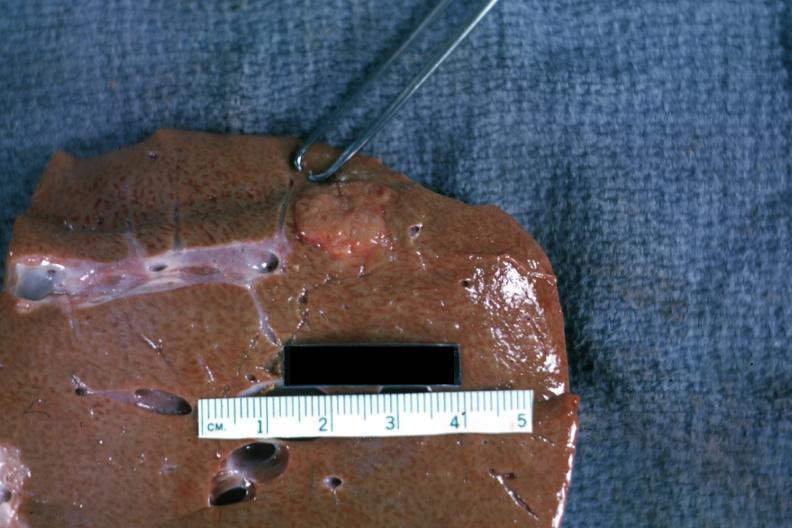what is present?
Answer the question using a single word or phrase. Liver 